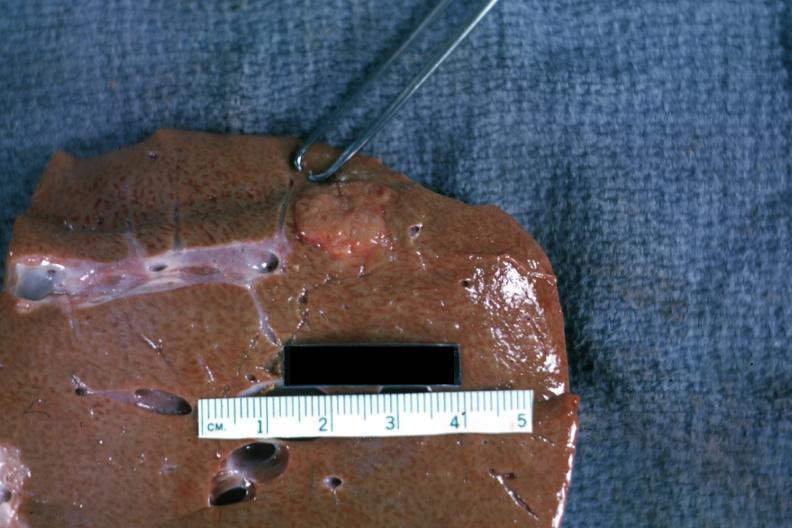what is present?
Answer the question using a single word or phrase. Liver 